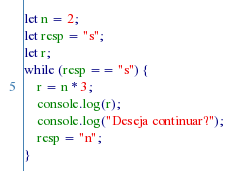<code> <loc_0><loc_0><loc_500><loc_500><_JavaScript_>let n = 2;
let resp = "s";
let r;
while (resp == "s") {
    r = n * 3;
    console.log(r);
    console.log("Deseja continuar?");
    resp = "n";
}</code> 